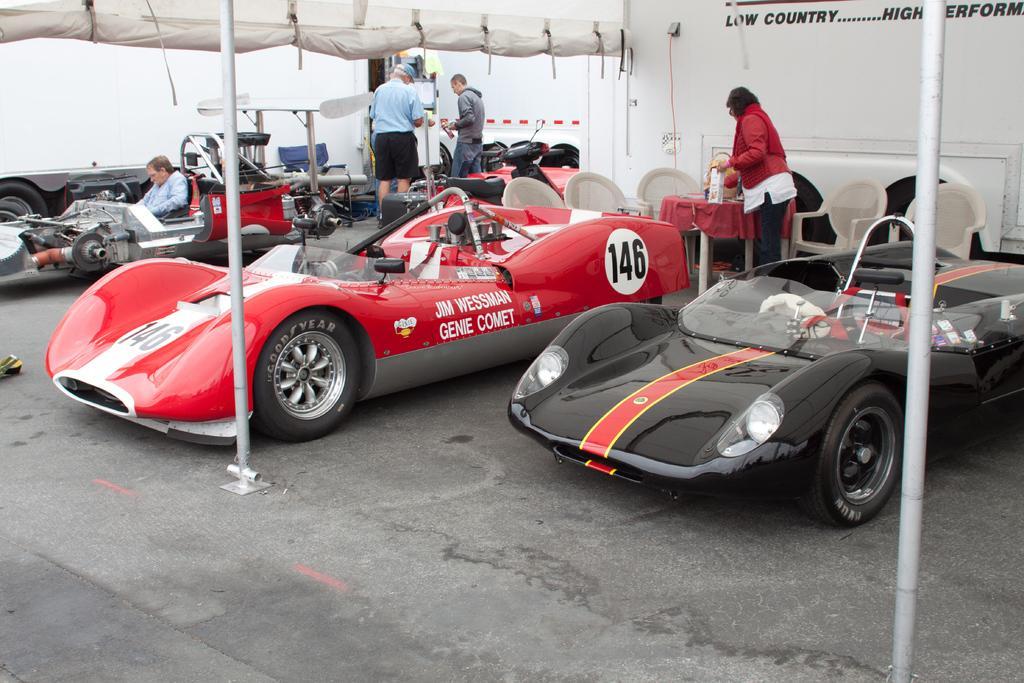In one or two sentences, can you explain what this image depicts? In this image I can see few vehicles. In front the vehicle is in red color, background I can see few other persons standing and the person is wearing red jacket, white shirt and black pant, and I can see white color background. 